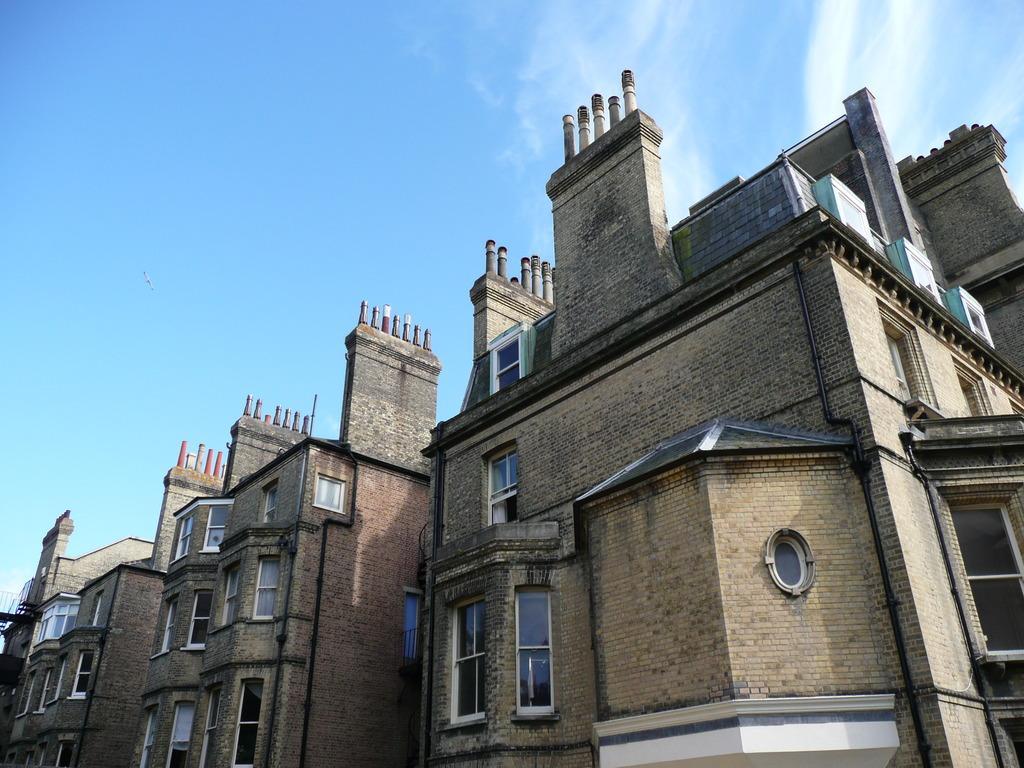How would you summarize this image in a sentence or two? In the center of the image there are buildings. At the top there is sky. 